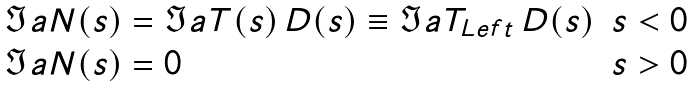<formula> <loc_0><loc_0><loc_500><loc_500>\begin{array} { l l } \Im a N ( s ) = \Im a T ( s ) \, D ( s ) \equiv \Im a T _ { L e f t } \, D ( s ) & s < 0 \\ \Im a N ( s ) = 0 & s > 0 \end{array}</formula> 